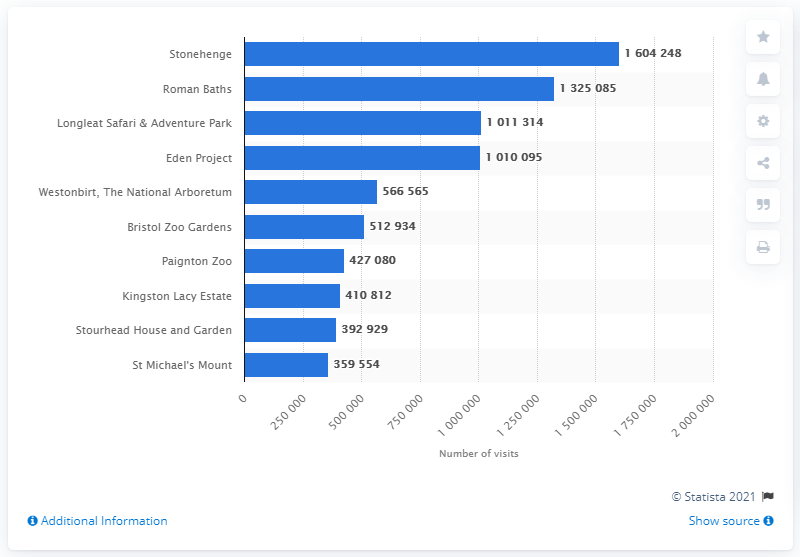Give some essential details in this illustration. In 2019, a total of 1604248 people visited Stonehenge. The most visited paid attraction in South West England in 2019 was Stonehenge. 